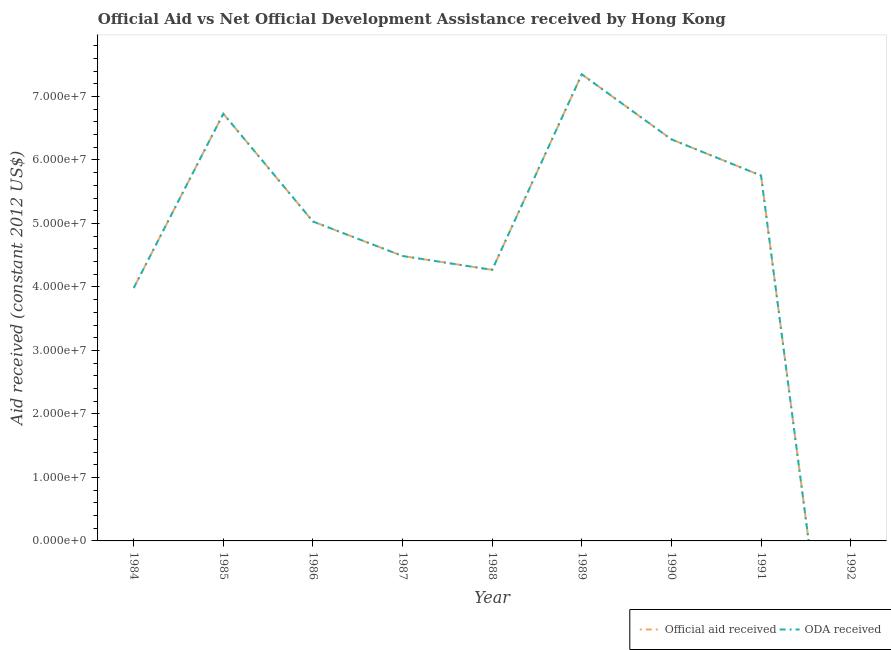Does the line corresponding to oda received intersect with the line corresponding to official aid received?
Give a very brief answer. Yes. What is the oda received in 1986?
Your answer should be very brief. 5.03e+07. Across all years, what is the maximum official aid received?
Your answer should be compact. 7.35e+07. Across all years, what is the minimum official aid received?
Offer a terse response. 0. In which year was the oda received maximum?
Offer a very short reply. 1989. What is the total oda received in the graph?
Make the answer very short. 4.39e+08. What is the difference between the oda received in 1990 and that in 1991?
Your answer should be compact. 5.71e+06. What is the difference between the oda received in 1989 and the official aid received in 1988?
Make the answer very short. 3.08e+07. What is the average oda received per year?
Offer a very short reply. 4.88e+07. In how many years, is the oda received greater than 30000000 US$?
Keep it short and to the point. 8. What is the ratio of the oda received in 1989 to that in 1991?
Offer a very short reply. 1.28. What is the difference between the highest and the second highest oda received?
Your answer should be very brief. 6.20e+06. What is the difference between the highest and the lowest official aid received?
Provide a short and direct response. 7.35e+07. Does the oda received monotonically increase over the years?
Provide a succinct answer. No. How many lines are there?
Offer a terse response. 2. How many years are there in the graph?
Provide a succinct answer. 9. Are the values on the major ticks of Y-axis written in scientific E-notation?
Provide a short and direct response. Yes. What is the title of the graph?
Provide a succinct answer. Official Aid vs Net Official Development Assistance received by Hong Kong . What is the label or title of the Y-axis?
Make the answer very short. Aid received (constant 2012 US$). What is the Aid received (constant 2012 US$) of Official aid received in 1984?
Keep it short and to the point. 3.98e+07. What is the Aid received (constant 2012 US$) of ODA received in 1984?
Give a very brief answer. 3.98e+07. What is the Aid received (constant 2012 US$) of Official aid received in 1985?
Your answer should be very brief. 6.73e+07. What is the Aid received (constant 2012 US$) in ODA received in 1985?
Provide a succinct answer. 6.73e+07. What is the Aid received (constant 2012 US$) of Official aid received in 1986?
Offer a very short reply. 5.03e+07. What is the Aid received (constant 2012 US$) in ODA received in 1986?
Make the answer very short. 5.03e+07. What is the Aid received (constant 2012 US$) of Official aid received in 1987?
Provide a short and direct response. 4.49e+07. What is the Aid received (constant 2012 US$) of ODA received in 1987?
Ensure brevity in your answer.  4.49e+07. What is the Aid received (constant 2012 US$) of Official aid received in 1988?
Your response must be concise. 4.27e+07. What is the Aid received (constant 2012 US$) in ODA received in 1988?
Give a very brief answer. 4.27e+07. What is the Aid received (constant 2012 US$) of Official aid received in 1989?
Provide a short and direct response. 7.35e+07. What is the Aid received (constant 2012 US$) in ODA received in 1989?
Ensure brevity in your answer.  7.35e+07. What is the Aid received (constant 2012 US$) in Official aid received in 1990?
Offer a terse response. 6.32e+07. What is the Aid received (constant 2012 US$) of ODA received in 1990?
Offer a very short reply. 6.32e+07. What is the Aid received (constant 2012 US$) in Official aid received in 1991?
Offer a terse response. 5.75e+07. What is the Aid received (constant 2012 US$) of ODA received in 1991?
Offer a very short reply. 5.75e+07. Across all years, what is the maximum Aid received (constant 2012 US$) of Official aid received?
Give a very brief answer. 7.35e+07. Across all years, what is the maximum Aid received (constant 2012 US$) in ODA received?
Your response must be concise. 7.35e+07. Across all years, what is the minimum Aid received (constant 2012 US$) in Official aid received?
Offer a terse response. 0. Across all years, what is the minimum Aid received (constant 2012 US$) in ODA received?
Make the answer very short. 0. What is the total Aid received (constant 2012 US$) of Official aid received in the graph?
Give a very brief answer. 4.39e+08. What is the total Aid received (constant 2012 US$) in ODA received in the graph?
Your response must be concise. 4.39e+08. What is the difference between the Aid received (constant 2012 US$) of Official aid received in 1984 and that in 1985?
Your answer should be very brief. -2.74e+07. What is the difference between the Aid received (constant 2012 US$) of ODA received in 1984 and that in 1985?
Your answer should be very brief. -2.74e+07. What is the difference between the Aid received (constant 2012 US$) in Official aid received in 1984 and that in 1986?
Provide a short and direct response. -1.05e+07. What is the difference between the Aid received (constant 2012 US$) in ODA received in 1984 and that in 1986?
Keep it short and to the point. -1.05e+07. What is the difference between the Aid received (constant 2012 US$) in Official aid received in 1984 and that in 1987?
Offer a terse response. -5.04e+06. What is the difference between the Aid received (constant 2012 US$) of ODA received in 1984 and that in 1987?
Ensure brevity in your answer.  -5.04e+06. What is the difference between the Aid received (constant 2012 US$) of Official aid received in 1984 and that in 1988?
Make the answer very short. -2.86e+06. What is the difference between the Aid received (constant 2012 US$) of ODA received in 1984 and that in 1988?
Give a very brief answer. -2.86e+06. What is the difference between the Aid received (constant 2012 US$) in Official aid received in 1984 and that in 1989?
Ensure brevity in your answer.  -3.36e+07. What is the difference between the Aid received (constant 2012 US$) in ODA received in 1984 and that in 1989?
Offer a very short reply. -3.36e+07. What is the difference between the Aid received (constant 2012 US$) of Official aid received in 1984 and that in 1990?
Ensure brevity in your answer.  -2.34e+07. What is the difference between the Aid received (constant 2012 US$) in ODA received in 1984 and that in 1990?
Make the answer very short. -2.34e+07. What is the difference between the Aid received (constant 2012 US$) in Official aid received in 1984 and that in 1991?
Offer a terse response. -1.77e+07. What is the difference between the Aid received (constant 2012 US$) in ODA received in 1984 and that in 1991?
Make the answer very short. -1.77e+07. What is the difference between the Aid received (constant 2012 US$) of Official aid received in 1985 and that in 1986?
Provide a succinct answer. 1.70e+07. What is the difference between the Aid received (constant 2012 US$) of ODA received in 1985 and that in 1986?
Provide a succinct answer. 1.70e+07. What is the difference between the Aid received (constant 2012 US$) of Official aid received in 1985 and that in 1987?
Your answer should be compact. 2.24e+07. What is the difference between the Aid received (constant 2012 US$) in ODA received in 1985 and that in 1987?
Provide a short and direct response. 2.24e+07. What is the difference between the Aid received (constant 2012 US$) in Official aid received in 1985 and that in 1988?
Your response must be concise. 2.46e+07. What is the difference between the Aid received (constant 2012 US$) in ODA received in 1985 and that in 1988?
Offer a terse response. 2.46e+07. What is the difference between the Aid received (constant 2012 US$) of Official aid received in 1985 and that in 1989?
Your answer should be very brief. -6.20e+06. What is the difference between the Aid received (constant 2012 US$) of ODA received in 1985 and that in 1989?
Keep it short and to the point. -6.20e+06. What is the difference between the Aid received (constant 2012 US$) of Official aid received in 1985 and that in 1990?
Your answer should be very brief. 4.04e+06. What is the difference between the Aid received (constant 2012 US$) of ODA received in 1985 and that in 1990?
Provide a succinct answer. 4.04e+06. What is the difference between the Aid received (constant 2012 US$) in Official aid received in 1985 and that in 1991?
Ensure brevity in your answer.  9.75e+06. What is the difference between the Aid received (constant 2012 US$) of ODA received in 1985 and that in 1991?
Provide a succinct answer. 9.75e+06. What is the difference between the Aid received (constant 2012 US$) of Official aid received in 1986 and that in 1987?
Ensure brevity in your answer.  5.43e+06. What is the difference between the Aid received (constant 2012 US$) in ODA received in 1986 and that in 1987?
Offer a terse response. 5.43e+06. What is the difference between the Aid received (constant 2012 US$) of Official aid received in 1986 and that in 1988?
Make the answer very short. 7.61e+06. What is the difference between the Aid received (constant 2012 US$) in ODA received in 1986 and that in 1988?
Offer a very short reply. 7.61e+06. What is the difference between the Aid received (constant 2012 US$) in Official aid received in 1986 and that in 1989?
Ensure brevity in your answer.  -2.32e+07. What is the difference between the Aid received (constant 2012 US$) in ODA received in 1986 and that in 1989?
Provide a short and direct response. -2.32e+07. What is the difference between the Aid received (constant 2012 US$) of Official aid received in 1986 and that in 1990?
Make the answer very short. -1.29e+07. What is the difference between the Aid received (constant 2012 US$) of ODA received in 1986 and that in 1990?
Provide a succinct answer. -1.29e+07. What is the difference between the Aid received (constant 2012 US$) of Official aid received in 1986 and that in 1991?
Offer a terse response. -7.23e+06. What is the difference between the Aid received (constant 2012 US$) in ODA received in 1986 and that in 1991?
Your answer should be very brief. -7.23e+06. What is the difference between the Aid received (constant 2012 US$) of Official aid received in 1987 and that in 1988?
Make the answer very short. 2.18e+06. What is the difference between the Aid received (constant 2012 US$) of ODA received in 1987 and that in 1988?
Offer a terse response. 2.18e+06. What is the difference between the Aid received (constant 2012 US$) in Official aid received in 1987 and that in 1989?
Keep it short and to the point. -2.86e+07. What is the difference between the Aid received (constant 2012 US$) in ODA received in 1987 and that in 1989?
Your response must be concise. -2.86e+07. What is the difference between the Aid received (constant 2012 US$) in Official aid received in 1987 and that in 1990?
Make the answer very short. -1.84e+07. What is the difference between the Aid received (constant 2012 US$) of ODA received in 1987 and that in 1990?
Provide a short and direct response. -1.84e+07. What is the difference between the Aid received (constant 2012 US$) in Official aid received in 1987 and that in 1991?
Keep it short and to the point. -1.27e+07. What is the difference between the Aid received (constant 2012 US$) of ODA received in 1987 and that in 1991?
Ensure brevity in your answer.  -1.27e+07. What is the difference between the Aid received (constant 2012 US$) in Official aid received in 1988 and that in 1989?
Provide a short and direct response. -3.08e+07. What is the difference between the Aid received (constant 2012 US$) in ODA received in 1988 and that in 1989?
Offer a terse response. -3.08e+07. What is the difference between the Aid received (constant 2012 US$) of Official aid received in 1988 and that in 1990?
Make the answer very short. -2.06e+07. What is the difference between the Aid received (constant 2012 US$) of ODA received in 1988 and that in 1990?
Offer a very short reply. -2.06e+07. What is the difference between the Aid received (constant 2012 US$) of Official aid received in 1988 and that in 1991?
Give a very brief answer. -1.48e+07. What is the difference between the Aid received (constant 2012 US$) of ODA received in 1988 and that in 1991?
Provide a succinct answer. -1.48e+07. What is the difference between the Aid received (constant 2012 US$) of Official aid received in 1989 and that in 1990?
Keep it short and to the point. 1.02e+07. What is the difference between the Aid received (constant 2012 US$) of ODA received in 1989 and that in 1990?
Provide a succinct answer. 1.02e+07. What is the difference between the Aid received (constant 2012 US$) in Official aid received in 1989 and that in 1991?
Your response must be concise. 1.60e+07. What is the difference between the Aid received (constant 2012 US$) of ODA received in 1989 and that in 1991?
Ensure brevity in your answer.  1.60e+07. What is the difference between the Aid received (constant 2012 US$) of Official aid received in 1990 and that in 1991?
Make the answer very short. 5.71e+06. What is the difference between the Aid received (constant 2012 US$) in ODA received in 1990 and that in 1991?
Make the answer very short. 5.71e+06. What is the difference between the Aid received (constant 2012 US$) in Official aid received in 1984 and the Aid received (constant 2012 US$) in ODA received in 1985?
Ensure brevity in your answer.  -2.74e+07. What is the difference between the Aid received (constant 2012 US$) in Official aid received in 1984 and the Aid received (constant 2012 US$) in ODA received in 1986?
Your answer should be very brief. -1.05e+07. What is the difference between the Aid received (constant 2012 US$) of Official aid received in 1984 and the Aid received (constant 2012 US$) of ODA received in 1987?
Keep it short and to the point. -5.04e+06. What is the difference between the Aid received (constant 2012 US$) in Official aid received in 1984 and the Aid received (constant 2012 US$) in ODA received in 1988?
Keep it short and to the point. -2.86e+06. What is the difference between the Aid received (constant 2012 US$) in Official aid received in 1984 and the Aid received (constant 2012 US$) in ODA received in 1989?
Your answer should be very brief. -3.36e+07. What is the difference between the Aid received (constant 2012 US$) of Official aid received in 1984 and the Aid received (constant 2012 US$) of ODA received in 1990?
Your answer should be very brief. -2.34e+07. What is the difference between the Aid received (constant 2012 US$) of Official aid received in 1984 and the Aid received (constant 2012 US$) of ODA received in 1991?
Your answer should be compact. -1.77e+07. What is the difference between the Aid received (constant 2012 US$) in Official aid received in 1985 and the Aid received (constant 2012 US$) in ODA received in 1986?
Your response must be concise. 1.70e+07. What is the difference between the Aid received (constant 2012 US$) of Official aid received in 1985 and the Aid received (constant 2012 US$) of ODA received in 1987?
Your answer should be very brief. 2.24e+07. What is the difference between the Aid received (constant 2012 US$) in Official aid received in 1985 and the Aid received (constant 2012 US$) in ODA received in 1988?
Your answer should be very brief. 2.46e+07. What is the difference between the Aid received (constant 2012 US$) of Official aid received in 1985 and the Aid received (constant 2012 US$) of ODA received in 1989?
Give a very brief answer. -6.20e+06. What is the difference between the Aid received (constant 2012 US$) in Official aid received in 1985 and the Aid received (constant 2012 US$) in ODA received in 1990?
Make the answer very short. 4.04e+06. What is the difference between the Aid received (constant 2012 US$) in Official aid received in 1985 and the Aid received (constant 2012 US$) in ODA received in 1991?
Offer a very short reply. 9.75e+06. What is the difference between the Aid received (constant 2012 US$) of Official aid received in 1986 and the Aid received (constant 2012 US$) of ODA received in 1987?
Offer a very short reply. 5.43e+06. What is the difference between the Aid received (constant 2012 US$) in Official aid received in 1986 and the Aid received (constant 2012 US$) in ODA received in 1988?
Ensure brevity in your answer.  7.61e+06. What is the difference between the Aid received (constant 2012 US$) of Official aid received in 1986 and the Aid received (constant 2012 US$) of ODA received in 1989?
Make the answer very short. -2.32e+07. What is the difference between the Aid received (constant 2012 US$) in Official aid received in 1986 and the Aid received (constant 2012 US$) in ODA received in 1990?
Your answer should be compact. -1.29e+07. What is the difference between the Aid received (constant 2012 US$) in Official aid received in 1986 and the Aid received (constant 2012 US$) in ODA received in 1991?
Ensure brevity in your answer.  -7.23e+06. What is the difference between the Aid received (constant 2012 US$) in Official aid received in 1987 and the Aid received (constant 2012 US$) in ODA received in 1988?
Give a very brief answer. 2.18e+06. What is the difference between the Aid received (constant 2012 US$) of Official aid received in 1987 and the Aid received (constant 2012 US$) of ODA received in 1989?
Give a very brief answer. -2.86e+07. What is the difference between the Aid received (constant 2012 US$) of Official aid received in 1987 and the Aid received (constant 2012 US$) of ODA received in 1990?
Your answer should be very brief. -1.84e+07. What is the difference between the Aid received (constant 2012 US$) of Official aid received in 1987 and the Aid received (constant 2012 US$) of ODA received in 1991?
Your answer should be very brief. -1.27e+07. What is the difference between the Aid received (constant 2012 US$) of Official aid received in 1988 and the Aid received (constant 2012 US$) of ODA received in 1989?
Offer a terse response. -3.08e+07. What is the difference between the Aid received (constant 2012 US$) in Official aid received in 1988 and the Aid received (constant 2012 US$) in ODA received in 1990?
Offer a terse response. -2.06e+07. What is the difference between the Aid received (constant 2012 US$) in Official aid received in 1988 and the Aid received (constant 2012 US$) in ODA received in 1991?
Provide a short and direct response. -1.48e+07. What is the difference between the Aid received (constant 2012 US$) of Official aid received in 1989 and the Aid received (constant 2012 US$) of ODA received in 1990?
Offer a terse response. 1.02e+07. What is the difference between the Aid received (constant 2012 US$) in Official aid received in 1989 and the Aid received (constant 2012 US$) in ODA received in 1991?
Give a very brief answer. 1.60e+07. What is the difference between the Aid received (constant 2012 US$) in Official aid received in 1990 and the Aid received (constant 2012 US$) in ODA received in 1991?
Offer a terse response. 5.71e+06. What is the average Aid received (constant 2012 US$) in Official aid received per year?
Provide a short and direct response. 4.88e+07. What is the average Aid received (constant 2012 US$) in ODA received per year?
Your response must be concise. 4.88e+07. In the year 1985, what is the difference between the Aid received (constant 2012 US$) in Official aid received and Aid received (constant 2012 US$) in ODA received?
Provide a succinct answer. 0. In the year 1987, what is the difference between the Aid received (constant 2012 US$) in Official aid received and Aid received (constant 2012 US$) in ODA received?
Keep it short and to the point. 0. In the year 1988, what is the difference between the Aid received (constant 2012 US$) of Official aid received and Aid received (constant 2012 US$) of ODA received?
Your answer should be very brief. 0. In the year 1989, what is the difference between the Aid received (constant 2012 US$) in Official aid received and Aid received (constant 2012 US$) in ODA received?
Offer a terse response. 0. What is the ratio of the Aid received (constant 2012 US$) in Official aid received in 1984 to that in 1985?
Make the answer very short. 0.59. What is the ratio of the Aid received (constant 2012 US$) of ODA received in 1984 to that in 1985?
Ensure brevity in your answer.  0.59. What is the ratio of the Aid received (constant 2012 US$) of Official aid received in 1984 to that in 1986?
Offer a very short reply. 0.79. What is the ratio of the Aid received (constant 2012 US$) of ODA received in 1984 to that in 1986?
Your answer should be very brief. 0.79. What is the ratio of the Aid received (constant 2012 US$) in Official aid received in 1984 to that in 1987?
Offer a very short reply. 0.89. What is the ratio of the Aid received (constant 2012 US$) in ODA received in 1984 to that in 1987?
Your answer should be compact. 0.89. What is the ratio of the Aid received (constant 2012 US$) in Official aid received in 1984 to that in 1988?
Offer a terse response. 0.93. What is the ratio of the Aid received (constant 2012 US$) of ODA received in 1984 to that in 1988?
Offer a terse response. 0.93. What is the ratio of the Aid received (constant 2012 US$) of Official aid received in 1984 to that in 1989?
Give a very brief answer. 0.54. What is the ratio of the Aid received (constant 2012 US$) in ODA received in 1984 to that in 1989?
Keep it short and to the point. 0.54. What is the ratio of the Aid received (constant 2012 US$) in Official aid received in 1984 to that in 1990?
Provide a succinct answer. 0.63. What is the ratio of the Aid received (constant 2012 US$) in ODA received in 1984 to that in 1990?
Your answer should be compact. 0.63. What is the ratio of the Aid received (constant 2012 US$) of Official aid received in 1984 to that in 1991?
Keep it short and to the point. 0.69. What is the ratio of the Aid received (constant 2012 US$) in ODA received in 1984 to that in 1991?
Give a very brief answer. 0.69. What is the ratio of the Aid received (constant 2012 US$) of Official aid received in 1985 to that in 1986?
Offer a very short reply. 1.34. What is the ratio of the Aid received (constant 2012 US$) of ODA received in 1985 to that in 1986?
Offer a terse response. 1.34. What is the ratio of the Aid received (constant 2012 US$) of Official aid received in 1985 to that in 1987?
Provide a short and direct response. 1.5. What is the ratio of the Aid received (constant 2012 US$) in ODA received in 1985 to that in 1987?
Make the answer very short. 1.5. What is the ratio of the Aid received (constant 2012 US$) of Official aid received in 1985 to that in 1988?
Your response must be concise. 1.58. What is the ratio of the Aid received (constant 2012 US$) in ODA received in 1985 to that in 1988?
Ensure brevity in your answer.  1.58. What is the ratio of the Aid received (constant 2012 US$) in Official aid received in 1985 to that in 1989?
Keep it short and to the point. 0.92. What is the ratio of the Aid received (constant 2012 US$) of ODA received in 1985 to that in 1989?
Your answer should be very brief. 0.92. What is the ratio of the Aid received (constant 2012 US$) of Official aid received in 1985 to that in 1990?
Make the answer very short. 1.06. What is the ratio of the Aid received (constant 2012 US$) of ODA received in 1985 to that in 1990?
Offer a terse response. 1.06. What is the ratio of the Aid received (constant 2012 US$) in Official aid received in 1985 to that in 1991?
Give a very brief answer. 1.17. What is the ratio of the Aid received (constant 2012 US$) of ODA received in 1985 to that in 1991?
Your answer should be compact. 1.17. What is the ratio of the Aid received (constant 2012 US$) in Official aid received in 1986 to that in 1987?
Provide a succinct answer. 1.12. What is the ratio of the Aid received (constant 2012 US$) in ODA received in 1986 to that in 1987?
Keep it short and to the point. 1.12. What is the ratio of the Aid received (constant 2012 US$) of Official aid received in 1986 to that in 1988?
Offer a terse response. 1.18. What is the ratio of the Aid received (constant 2012 US$) in ODA received in 1986 to that in 1988?
Give a very brief answer. 1.18. What is the ratio of the Aid received (constant 2012 US$) of Official aid received in 1986 to that in 1989?
Give a very brief answer. 0.68. What is the ratio of the Aid received (constant 2012 US$) in ODA received in 1986 to that in 1989?
Your answer should be very brief. 0.68. What is the ratio of the Aid received (constant 2012 US$) in Official aid received in 1986 to that in 1990?
Ensure brevity in your answer.  0.8. What is the ratio of the Aid received (constant 2012 US$) of ODA received in 1986 to that in 1990?
Provide a succinct answer. 0.8. What is the ratio of the Aid received (constant 2012 US$) of Official aid received in 1986 to that in 1991?
Make the answer very short. 0.87. What is the ratio of the Aid received (constant 2012 US$) in ODA received in 1986 to that in 1991?
Your answer should be compact. 0.87. What is the ratio of the Aid received (constant 2012 US$) in Official aid received in 1987 to that in 1988?
Ensure brevity in your answer.  1.05. What is the ratio of the Aid received (constant 2012 US$) in ODA received in 1987 to that in 1988?
Your answer should be compact. 1.05. What is the ratio of the Aid received (constant 2012 US$) in Official aid received in 1987 to that in 1989?
Ensure brevity in your answer.  0.61. What is the ratio of the Aid received (constant 2012 US$) of ODA received in 1987 to that in 1989?
Your response must be concise. 0.61. What is the ratio of the Aid received (constant 2012 US$) in Official aid received in 1987 to that in 1990?
Provide a short and direct response. 0.71. What is the ratio of the Aid received (constant 2012 US$) in ODA received in 1987 to that in 1990?
Your answer should be compact. 0.71. What is the ratio of the Aid received (constant 2012 US$) of Official aid received in 1987 to that in 1991?
Make the answer very short. 0.78. What is the ratio of the Aid received (constant 2012 US$) of ODA received in 1987 to that in 1991?
Your answer should be compact. 0.78. What is the ratio of the Aid received (constant 2012 US$) of Official aid received in 1988 to that in 1989?
Make the answer very short. 0.58. What is the ratio of the Aid received (constant 2012 US$) in ODA received in 1988 to that in 1989?
Provide a succinct answer. 0.58. What is the ratio of the Aid received (constant 2012 US$) of Official aid received in 1988 to that in 1990?
Make the answer very short. 0.68. What is the ratio of the Aid received (constant 2012 US$) of ODA received in 1988 to that in 1990?
Your response must be concise. 0.68. What is the ratio of the Aid received (constant 2012 US$) of Official aid received in 1988 to that in 1991?
Your answer should be very brief. 0.74. What is the ratio of the Aid received (constant 2012 US$) of ODA received in 1988 to that in 1991?
Ensure brevity in your answer.  0.74. What is the ratio of the Aid received (constant 2012 US$) in Official aid received in 1989 to that in 1990?
Make the answer very short. 1.16. What is the ratio of the Aid received (constant 2012 US$) in ODA received in 1989 to that in 1990?
Keep it short and to the point. 1.16. What is the ratio of the Aid received (constant 2012 US$) in Official aid received in 1989 to that in 1991?
Offer a very short reply. 1.28. What is the ratio of the Aid received (constant 2012 US$) of ODA received in 1989 to that in 1991?
Your response must be concise. 1.28. What is the ratio of the Aid received (constant 2012 US$) of Official aid received in 1990 to that in 1991?
Your answer should be compact. 1.1. What is the ratio of the Aid received (constant 2012 US$) of ODA received in 1990 to that in 1991?
Your answer should be very brief. 1.1. What is the difference between the highest and the second highest Aid received (constant 2012 US$) in Official aid received?
Offer a very short reply. 6.20e+06. What is the difference between the highest and the second highest Aid received (constant 2012 US$) of ODA received?
Your response must be concise. 6.20e+06. What is the difference between the highest and the lowest Aid received (constant 2012 US$) of Official aid received?
Offer a very short reply. 7.35e+07. What is the difference between the highest and the lowest Aid received (constant 2012 US$) in ODA received?
Your response must be concise. 7.35e+07. 